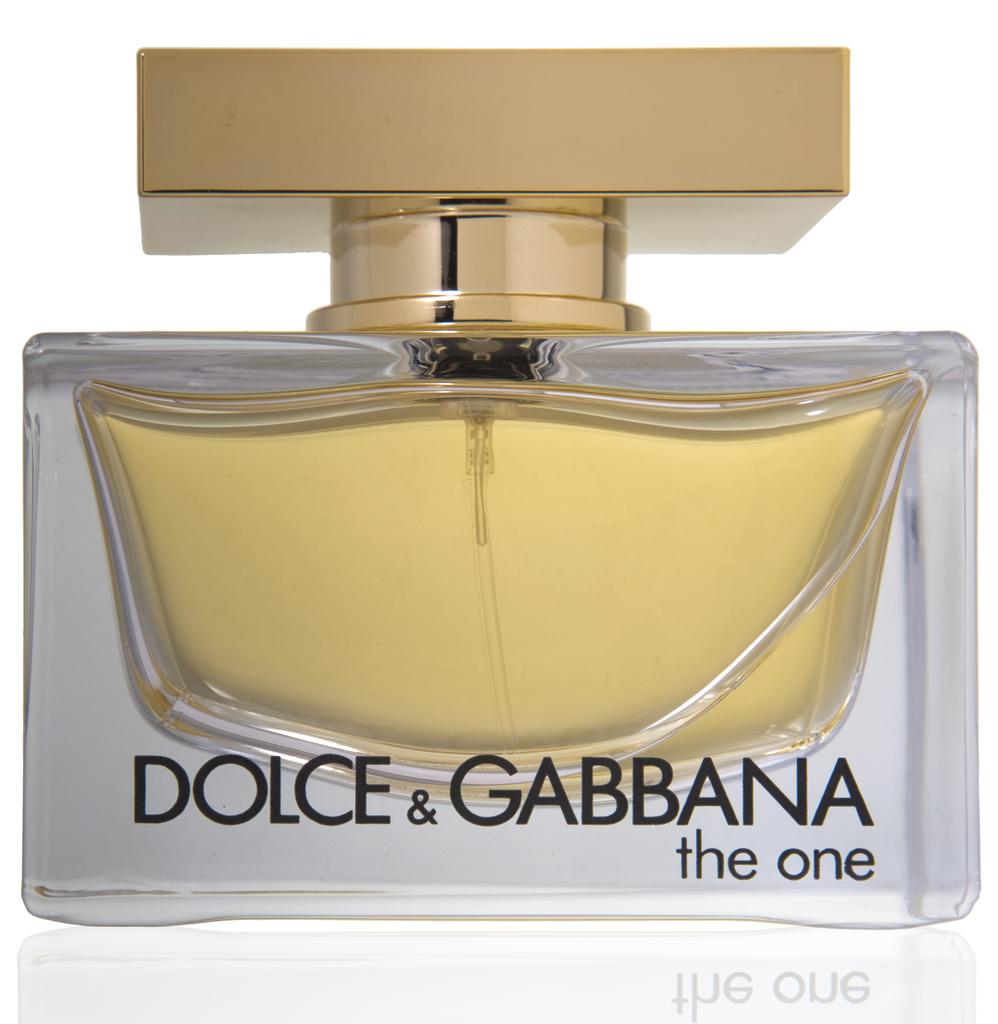What is the brand?
Your answer should be compact. Dolce & gabbana. 